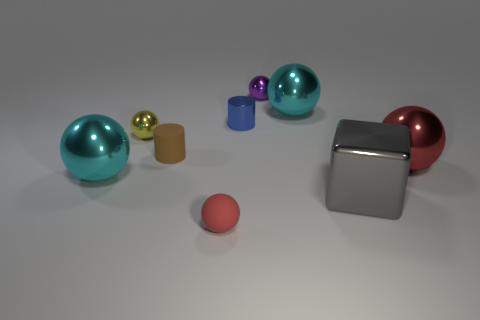How many objects are there in total, and can you describe their arrangement? There are a total of seven objects in the image, arranged from left to right as follows: a large cyan sphere, two smaller spheres (one gold, the other purple), two cylinders (one smaller and tan, the other larger and metallic), a small sphere which seems to be of a rubbery material, and finally a large maroon sphere on the far right. What could these objects represent in an abstract sense? Abstractly, these objects could represent different celestial bodies in a simplified model of a solar system, or they might symbolize various atoms or molecules in a molecular structure. Their varied sizes, shapes, and materials provide a visual diversity that could be leveraged to symbolize diversity or uniqueness in a conceptual art piece. 